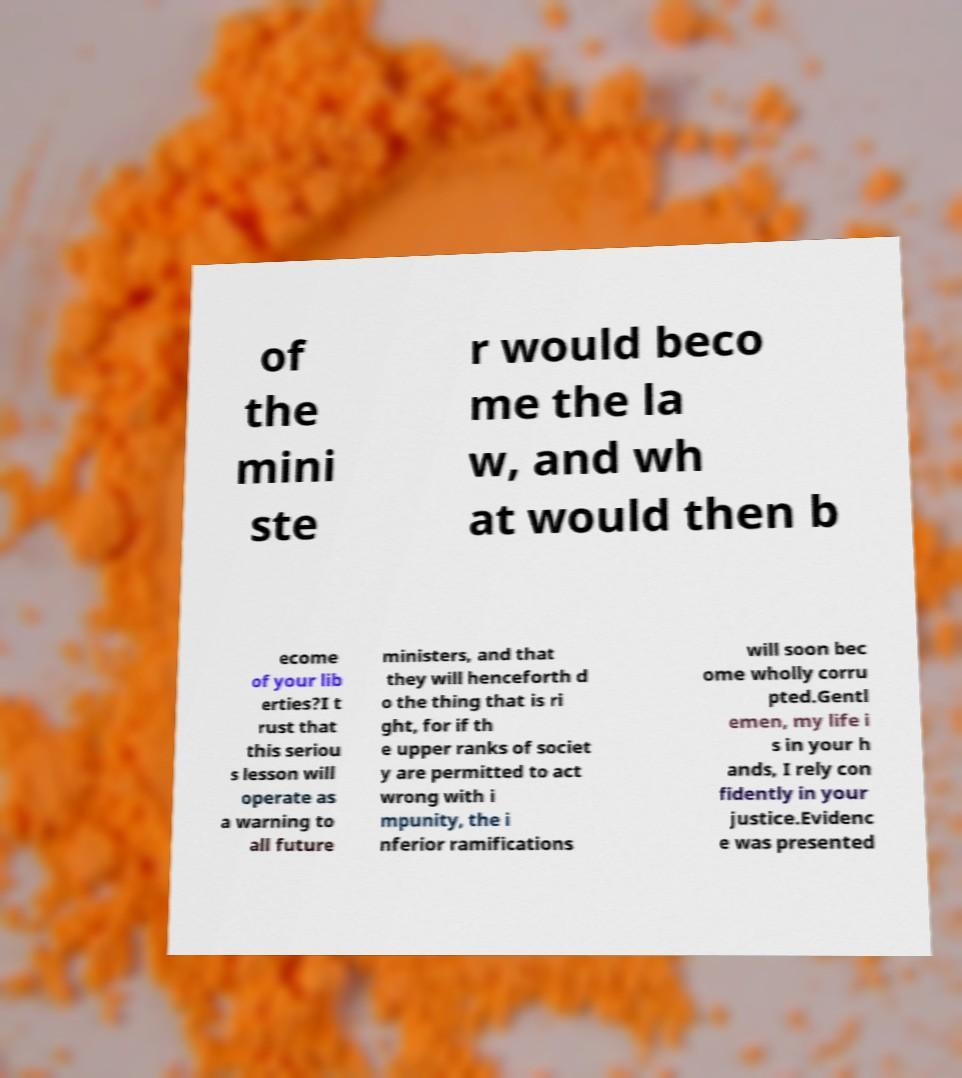What messages or text are displayed in this image? I need them in a readable, typed format. of the mini ste r would beco me the la w, and wh at would then b ecome of your lib erties?I t rust that this seriou s lesson will operate as a warning to all future ministers, and that they will henceforth d o the thing that is ri ght, for if th e upper ranks of societ y are permitted to act wrong with i mpunity, the i nferior ramifications will soon bec ome wholly corru pted.Gentl emen, my life i s in your h ands, I rely con fidently in your justice.Evidenc e was presented 